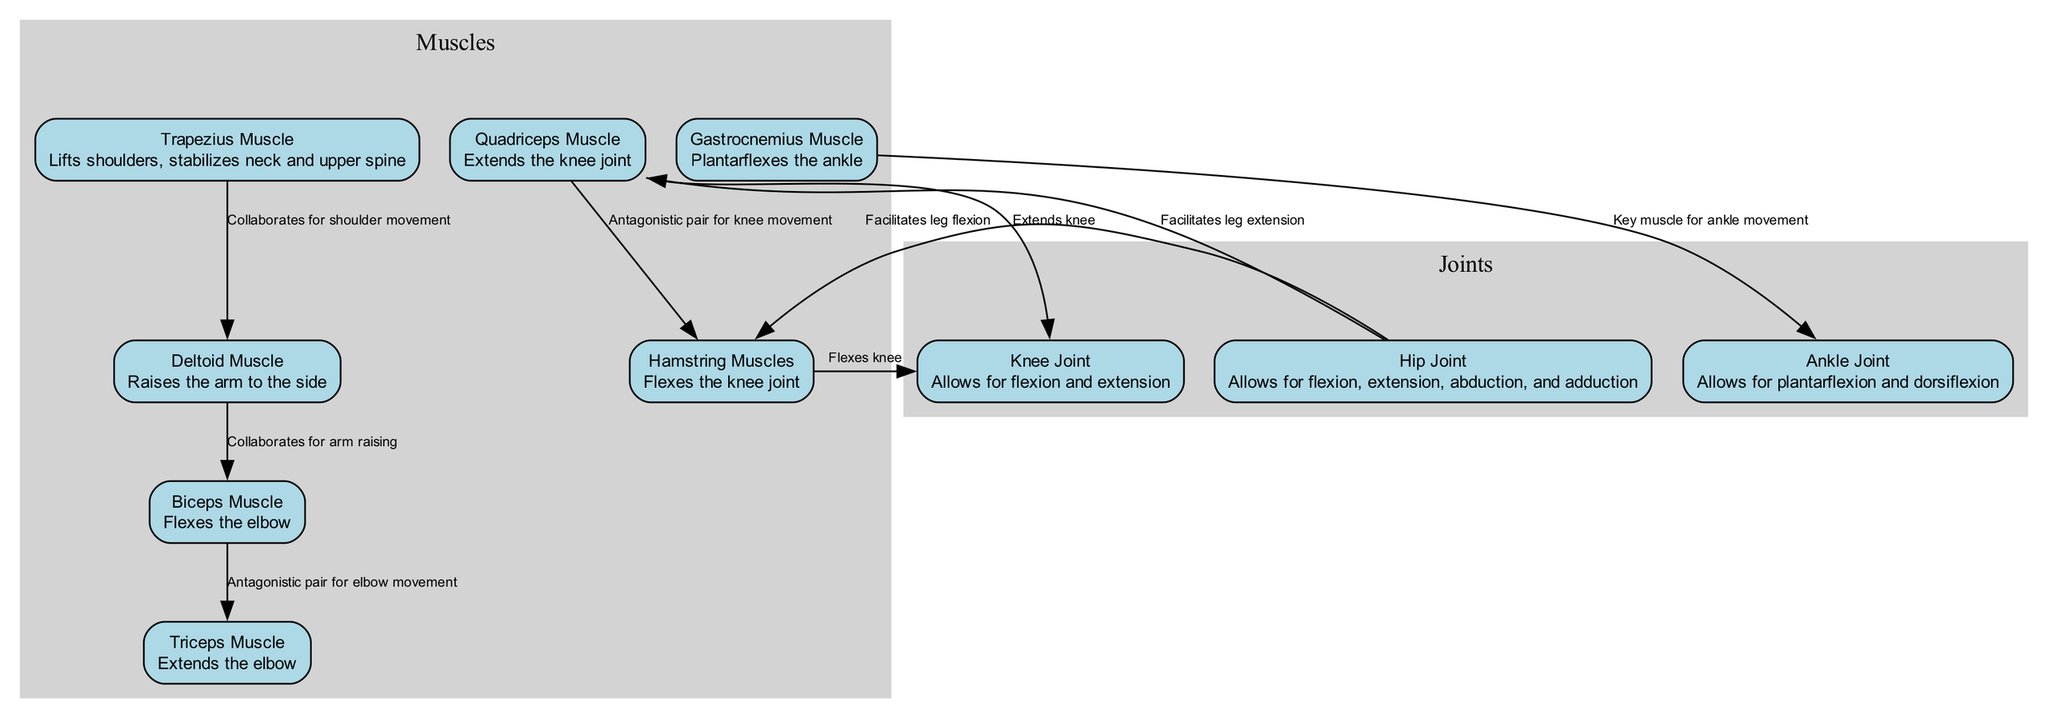What muscle is responsible for elbow flexion? The diagram indicates that the biceps muscle is listed as the muscle that flexes the elbow joint. Thus, when asked about the muscle responsible for this action, we look for the node that directly mentions elbow flexion and find "Biceps Muscle".
Answer: Biceps Muscle How do the quadriceps and hamstrings relate in knee movement? The relationship between the quadriceps and hamstrings indicates they are an antagonistic pair for knee movement, where the quadriceps extends the knee and the hamstrings flex the knee. Therefore, they work in opposition to control knee motion.
Answer: Antagonistic pair for knee movement Which joint allows for ankle plantarflexion? The ankle joint is specifically labeled in the diagram to allow for plantarflexion and dorsiflexion. When asked which joint facilitates this movement, we refer to the description connected to the ankle joint.
Answer: Ankle Joint What is the primary role of the gastrocnemius muscle in the diagram? In the diagram, the gastrocnemius muscle is labeled to indicate it is key for ankle movement, particularly plantarflexion. This role can be confirmed by reviewing its specific description within the diagram context.
Answer: Plantarflexes the ankle How does the hip joint facilitate movement of the quadriceps? The hip joint is described as facilitating leg extension, which directly relates to the function of the quadriceps muscle, as more extension action originates from it being activated. The connection shows how the hip joint supports this motion involving the quadriceps.
Answer: Facilitates leg extension What type of pair do the biceps and triceps form? The diagram shows that the biceps and triceps work in opposition as an antagonistic pair for elbow movement. This means they serve opposite functions in controlling the movement of the elbow, especially during flexion and extension.
Answer: Antagonistic pair How many muscles are identified in the diagram? By counting the listed muscle nodes within the diagram, we identify six distinct muscles: trapezius, deltoid, biceps, triceps, quadriceps, and hamstrings. This total gives us the count of muscle types referenced.
Answer: Six What does the deltoid muscle assist with? The diagram specifies that the deltoid muscle is responsible for raising the arm to the side. This direct description simplifies understanding its functional role during a jump shot in netball.
Answer: Raises the arm to the side 